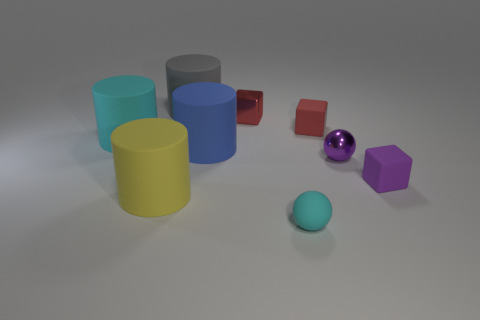Subtract all brown cylinders. How many red blocks are left? 2 Subtract all small red rubber blocks. How many blocks are left? 2 Add 1 tiny purple objects. How many objects exist? 10 Subtract all gray cylinders. How many cylinders are left? 3 Subtract all cylinders. How many objects are left? 5 Subtract all gray blocks. Subtract all purple cylinders. How many blocks are left? 3 Subtract all cylinders. Subtract all small blue shiny things. How many objects are left? 5 Add 4 large gray cylinders. How many large gray cylinders are left? 5 Add 4 large cyan things. How many large cyan things exist? 5 Subtract 0 brown blocks. How many objects are left? 9 